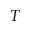Convert formula to latex. <formula><loc_0><loc_0><loc_500><loc_500>T</formula> 